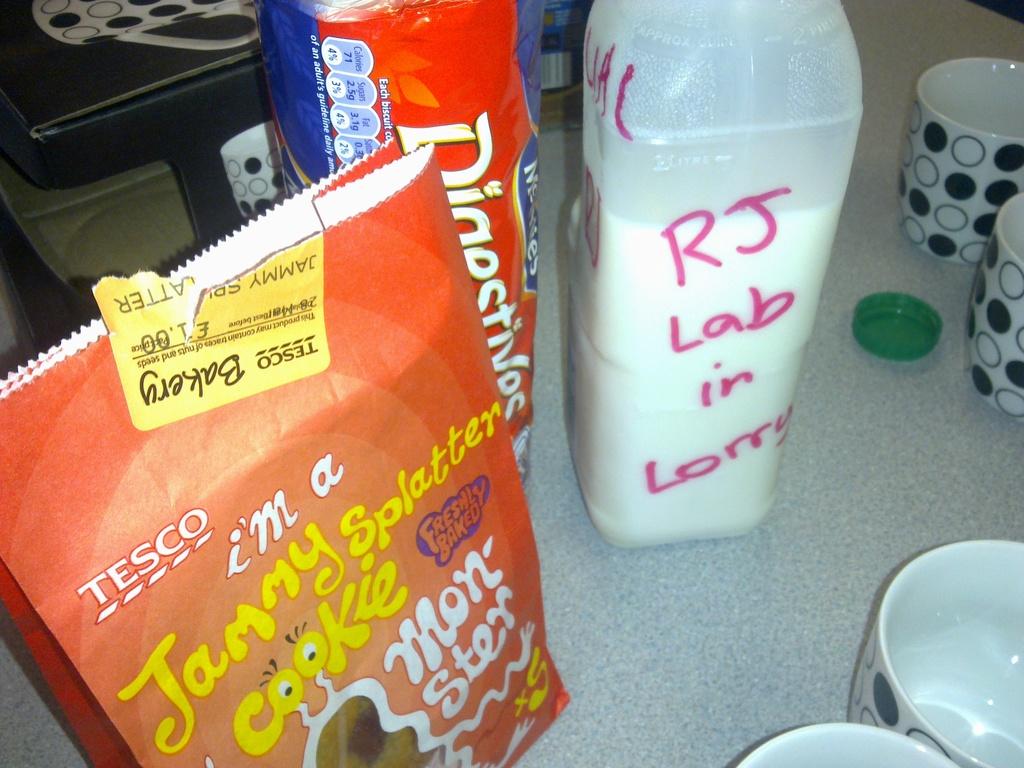What does the pink text say?
Provide a succinct answer. Rj lab in lorry. 